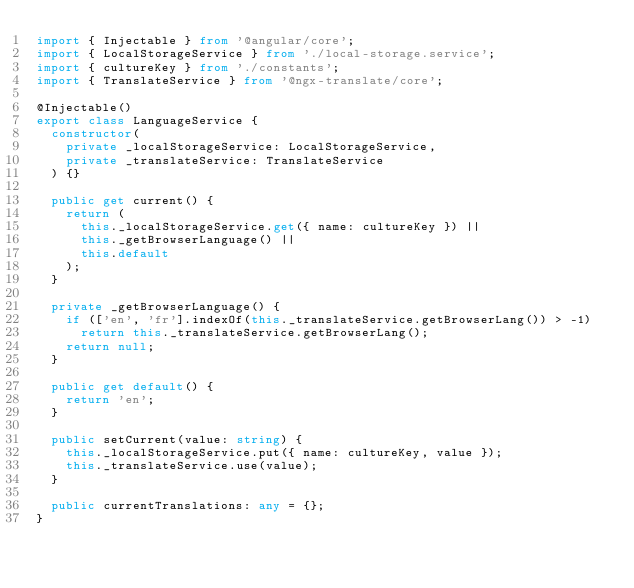<code> <loc_0><loc_0><loc_500><loc_500><_TypeScript_>import { Injectable } from '@angular/core';
import { LocalStorageService } from './local-storage.service';
import { cultureKey } from './constants';
import { TranslateService } from '@ngx-translate/core';

@Injectable()
export class LanguageService {
  constructor(
    private _localStorageService: LocalStorageService,
    private _translateService: TranslateService
  ) {}

  public get current() {
    return (
      this._localStorageService.get({ name: cultureKey }) ||
      this._getBrowserLanguage() ||
      this.default
    );
  }

  private _getBrowserLanguage() {
    if (['en', 'fr'].indexOf(this._translateService.getBrowserLang()) > -1)
      return this._translateService.getBrowserLang();
    return null;
  }

  public get default() {
    return 'en';
  }

  public setCurrent(value: string) {
    this._localStorageService.put({ name: cultureKey, value });
    this._translateService.use(value);
  }

  public currentTranslations: any = {};
}
</code> 